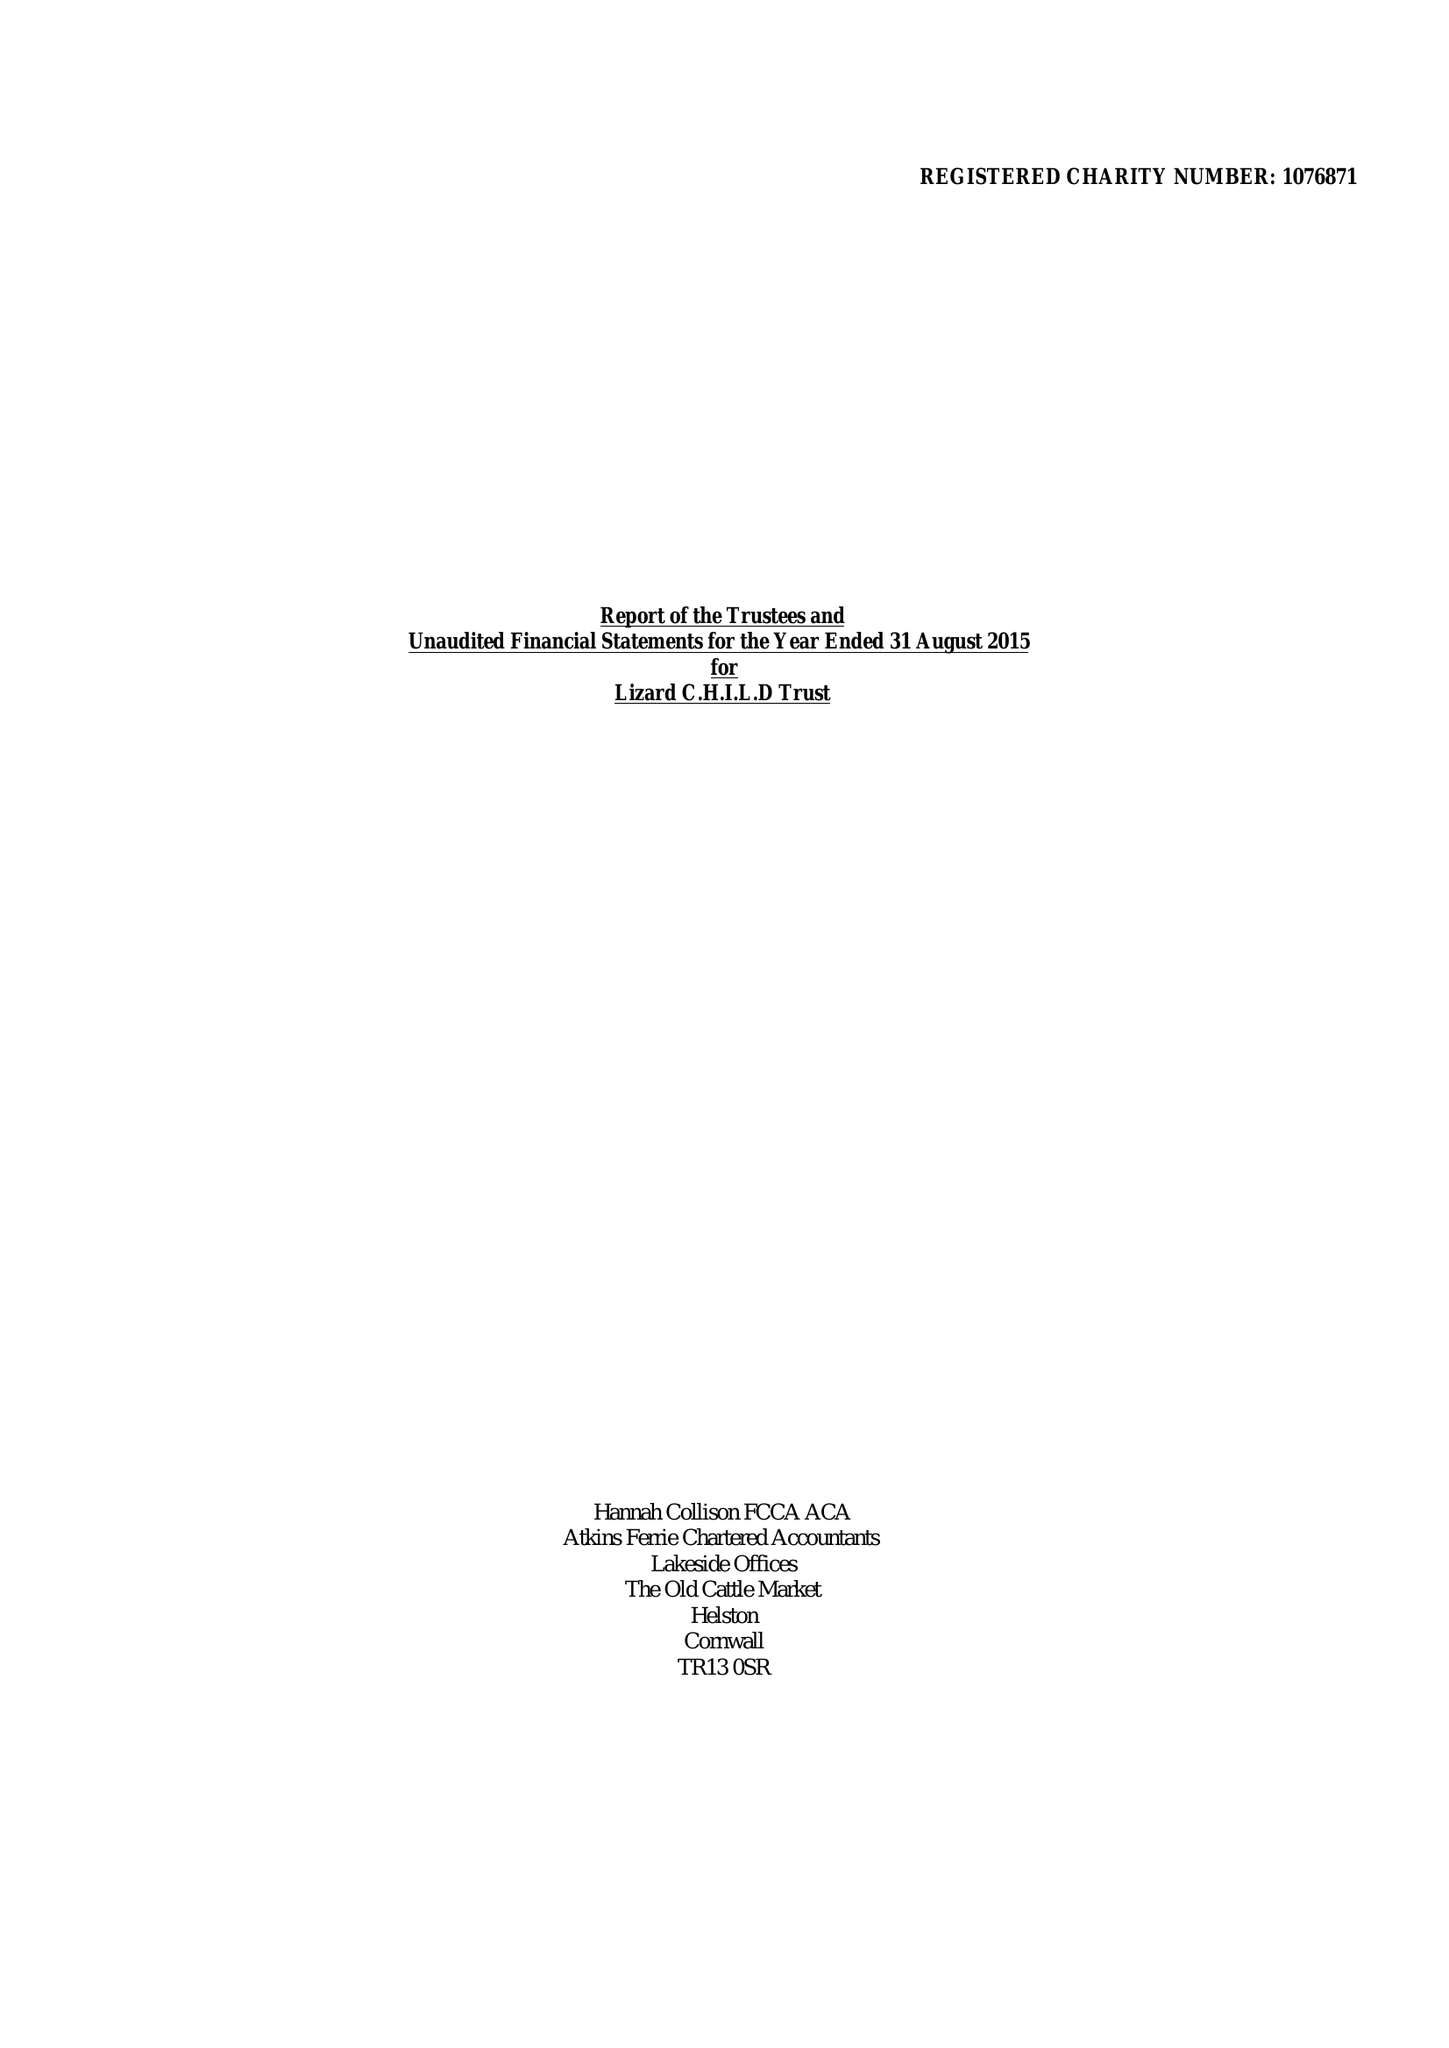What is the value for the charity_name?
Answer the question using a single word or phrase. Lizard C.H.I.L.D. Trust 